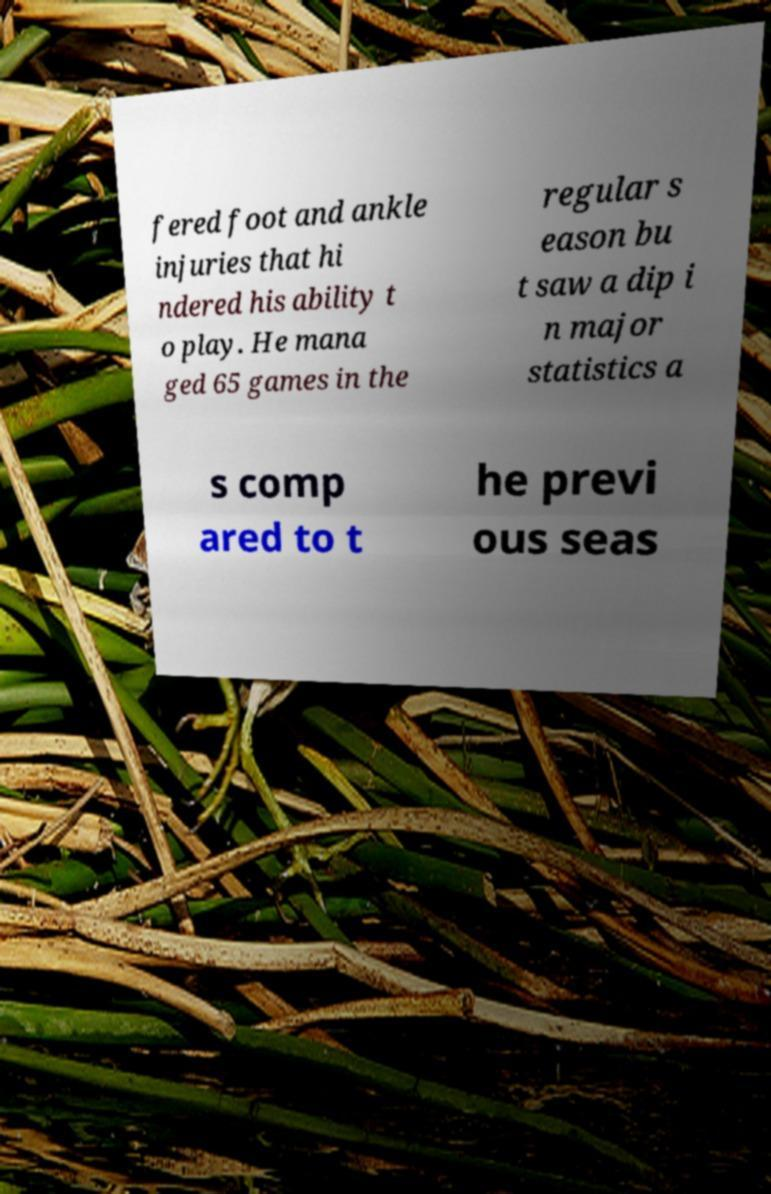I need the written content from this picture converted into text. Can you do that? fered foot and ankle injuries that hi ndered his ability t o play. He mana ged 65 games in the regular s eason bu t saw a dip i n major statistics a s comp ared to t he previ ous seas 